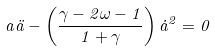<formula> <loc_0><loc_0><loc_500><loc_500>a \ddot { a } - \left ( \frac { \gamma - 2 \omega - 1 } { 1 + \gamma } \right ) \dot { a } ^ { 2 } = 0</formula> 